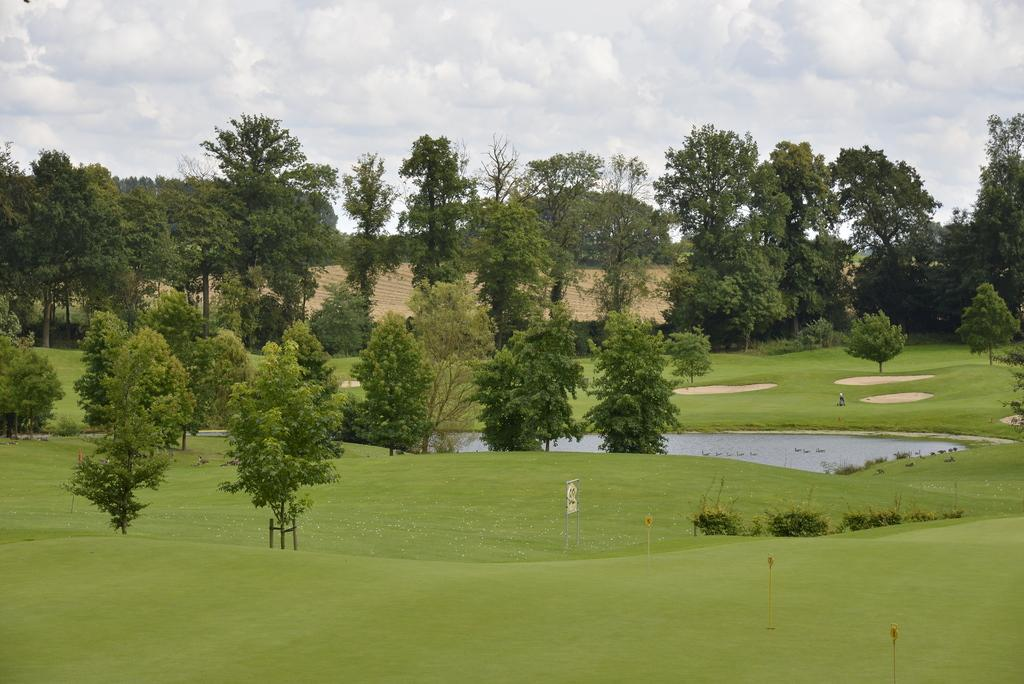What type of landscape is depicted in the image? There is a grassland in the image. What can be seen in the middle of the grassland? There is a pond in the middle of the image. Are there any other natural elements in the image? Yes, there are trees in the image. What is visible above the grassland and trees? The sky is visible in the image. Where is the birth of the newborn animal taking place in the image? There is no newborn animal or birth depicted in the image. What type of conversation is happening between the trees in the image? Trees do not engage in conversation, so there is no talk between the trees in the image. 